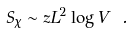Convert formula to latex. <formula><loc_0><loc_0><loc_500><loc_500>S _ { \chi } \sim z L ^ { 2 } \log V \ .</formula> 